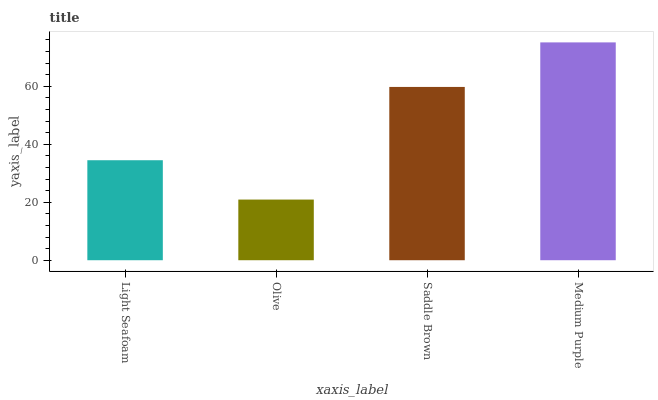Is Olive the minimum?
Answer yes or no. Yes. Is Medium Purple the maximum?
Answer yes or no. Yes. Is Saddle Brown the minimum?
Answer yes or no. No. Is Saddle Brown the maximum?
Answer yes or no. No. Is Saddle Brown greater than Olive?
Answer yes or no. Yes. Is Olive less than Saddle Brown?
Answer yes or no. Yes. Is Olive greater than Saddle Brown?
Answer yes or no. No. Is Saddle Brown less than Olive?
Answer yes or no. No. Is Saddle Brown the high median?
Answer yes or no. Yes. Is Light Seafoam the low median?
Answer yes or no. Yes. Is Light Seafoam the high median?
Answer yes or no. No. Is Saddle Brown the low median?
Answer yes or no. No. 